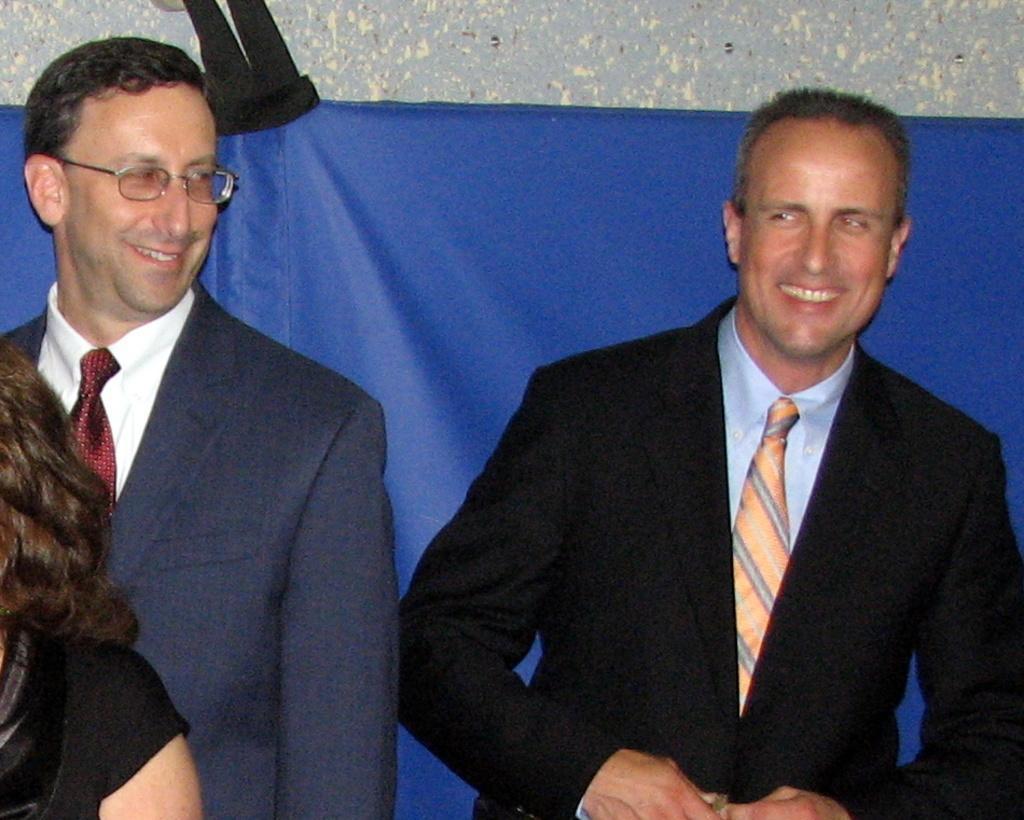Can you describe this image briefly? In this image, we can see two men in suits. They are smiling. Background there is a cloth and wall. Left side bottom corner, we can see human arm and hair. Here we can see black clothes. 